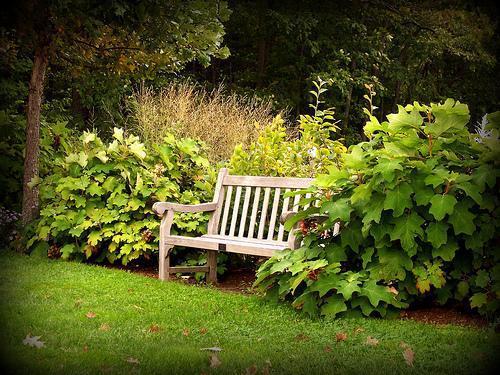How many benches are there?
Give a very brief answer. 1. 